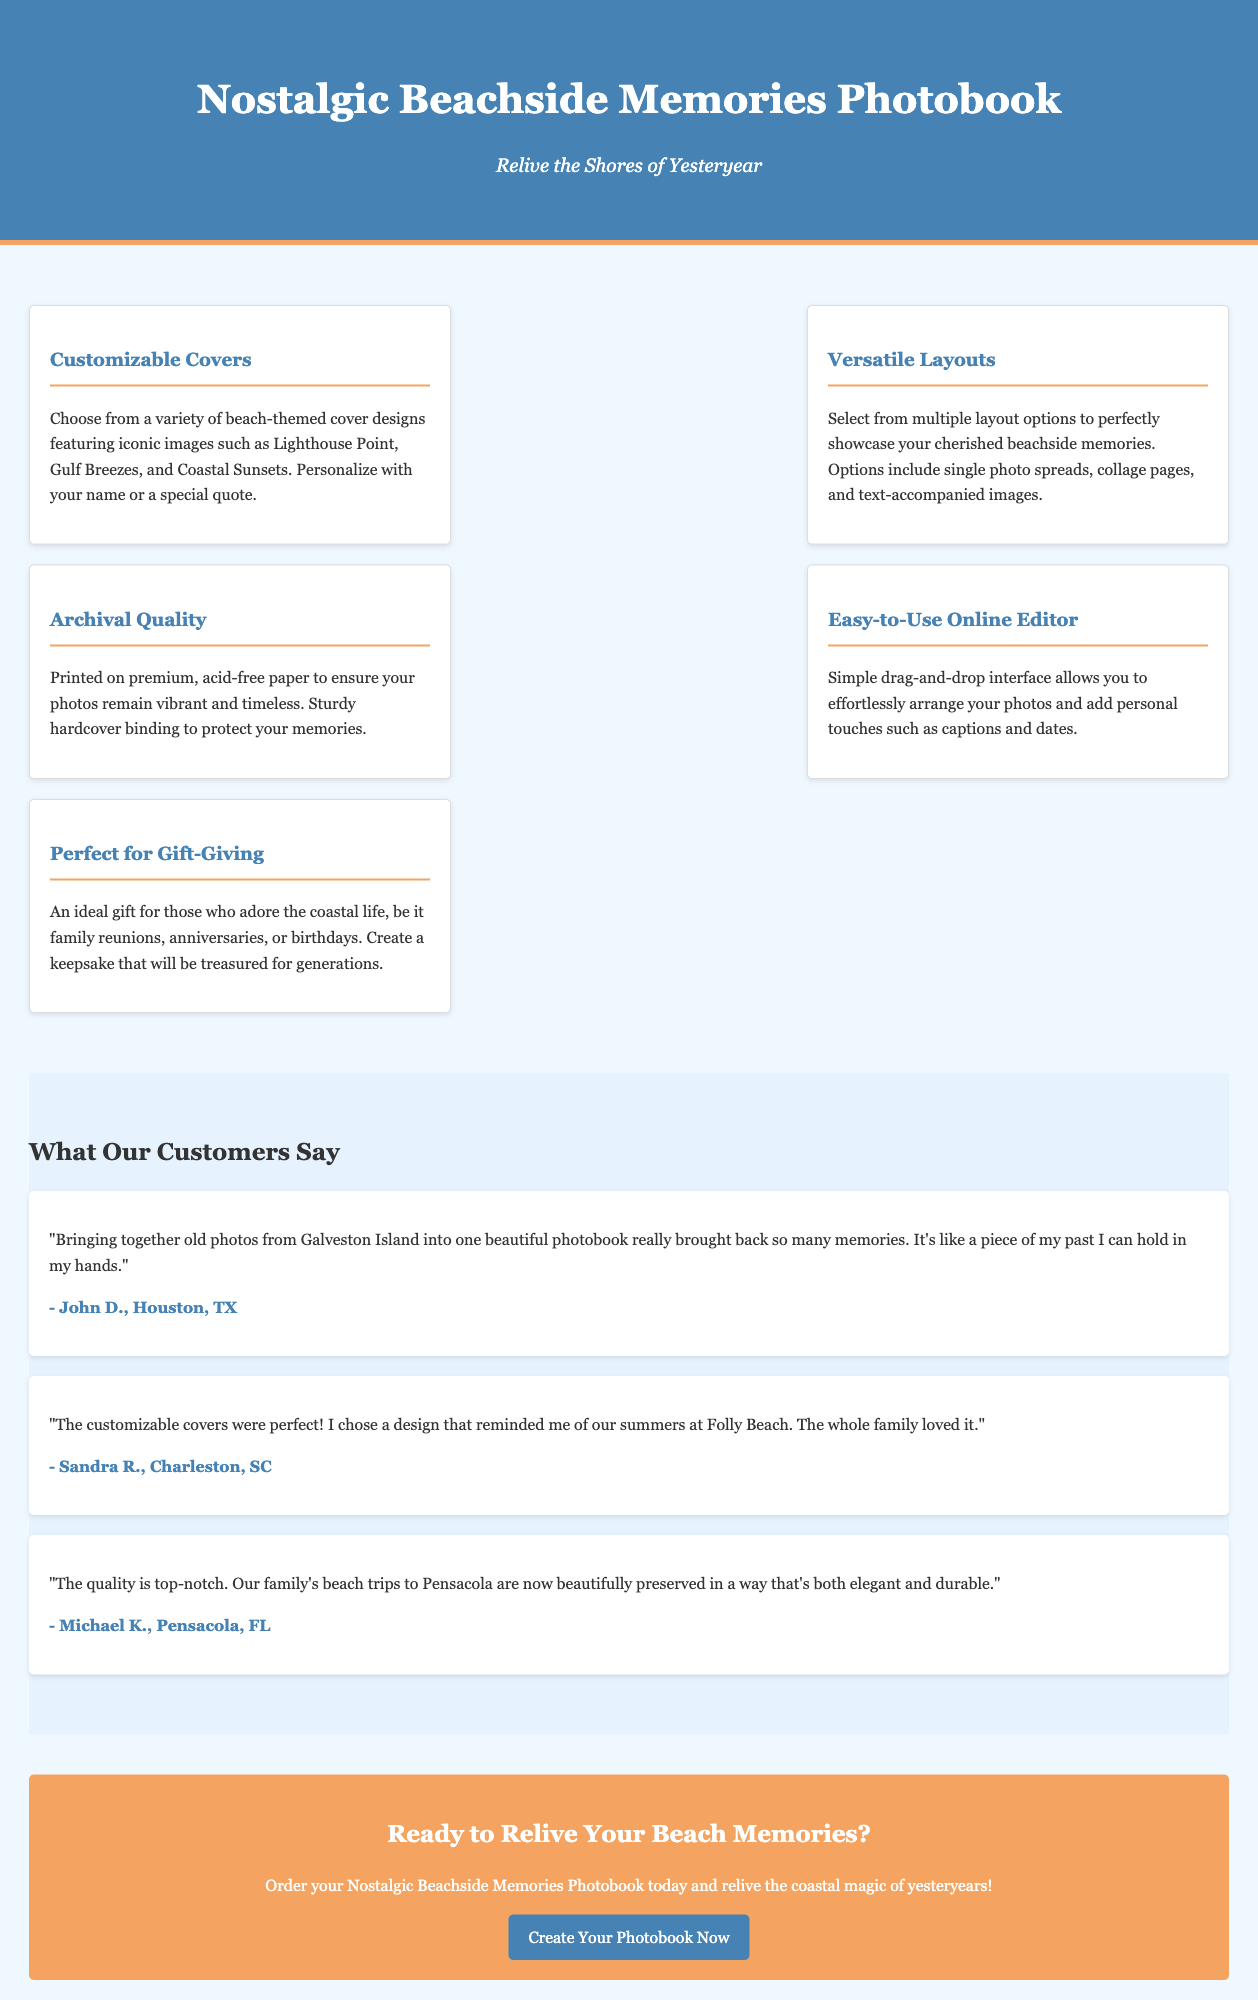what is the title of the photobook? The title is presented prominently in the header of the document.
Answer: Nostalgic Beachside Memories Photobook what are the customizable cover options? The document lists various beach-themed cover designs that can be personalized.
Answer: Lighthouse Point, Gulf Breezes, Coastal Sunsets how many layout options are mentioned? The document states that multiple layout options are available for showcasing memories.
Answer: Multiple what quality of paper is used for printing? This information is provided to emphasize the photobook's durability and longevity.
Answer: Acid-free paper who is a customer that praised the photobook? The testimonials section includes customers' names and locations who shared their experiences.
Answer: John D., Houston, TX what feature allows easy arrangement of photos? The document mentions a specific feature related to user interaction during the creating process.
Answer: Easy-to-Use Online Editor what is the ideal occasion for gifting the photobook? The document specifies occasions suitable for giving this photobook as a gift.
Answer: Family reunions, anniversaries, birthdays how does the customer describe the photobook's quality? The testimonial section provides customer feedback on the overall quality of the product.
Answer: Top-notch how does the document invite readers to act? The call-to-action section encourages readers to engage with the product offerings.
Answer: Create Your Photobook Now 